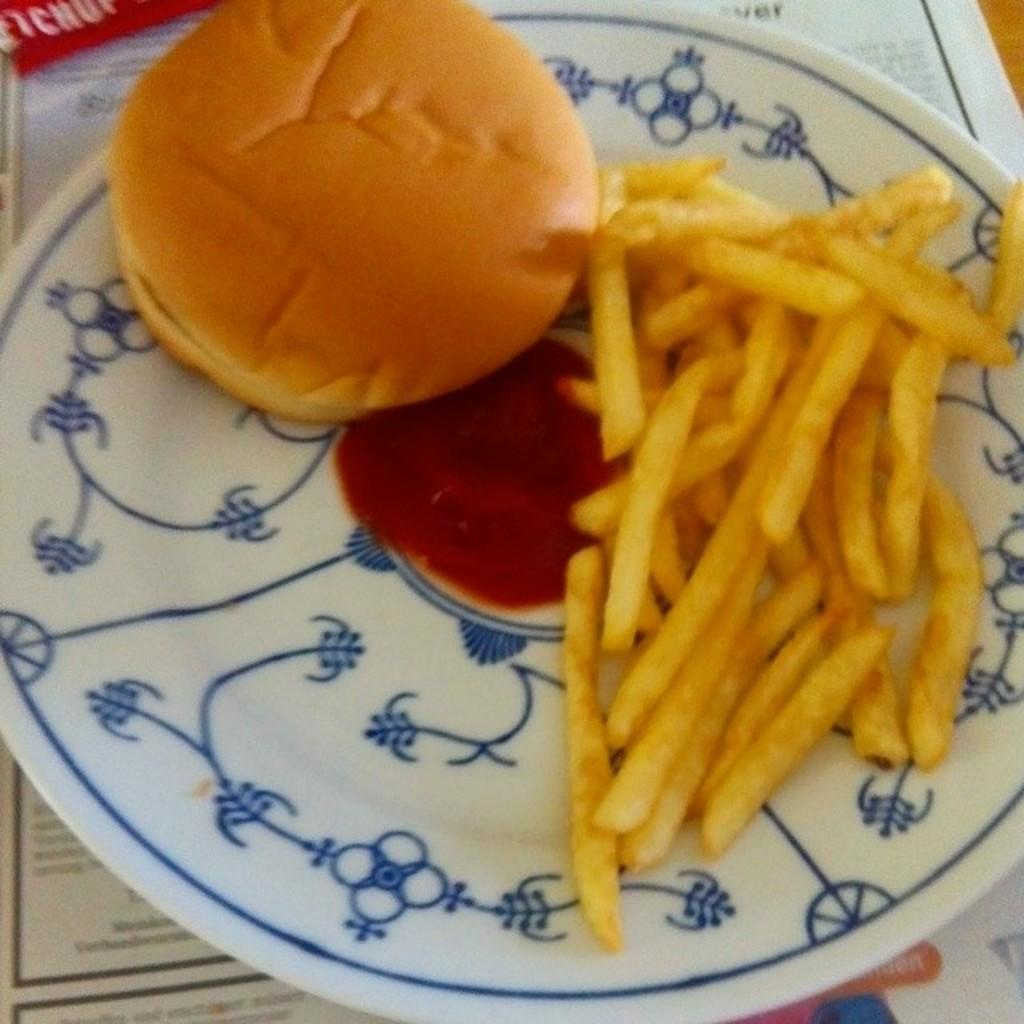What type of dish is used to serve the food in the image? The food is served on a white-colored plate in the image. What specific items can be seen in the food? The food includes buns and french fries. Where is the plate with the food located? The plate is placed on a table. Is there a veil covering the food in the image? No, there is no veil present in the image. Can you open the drawer to find more food in the image? There is no drawer present in the image. 